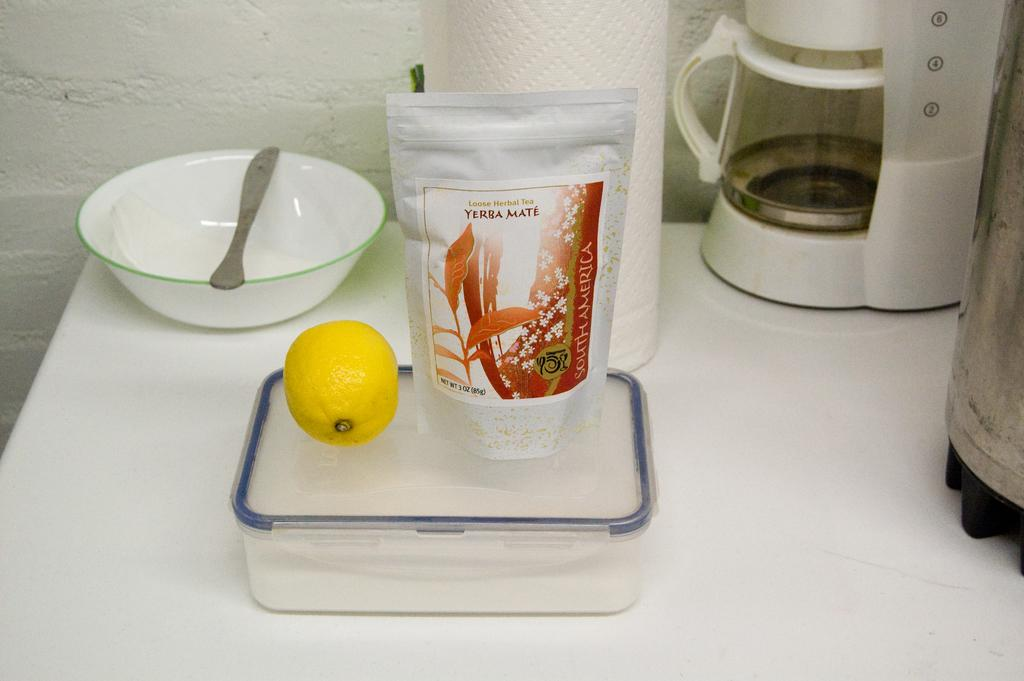<image>
Give a short and clear explanation of the subsequent image. Near a coffee maker a lemon is placed on a plastic container next to a bag of herbal tea. 